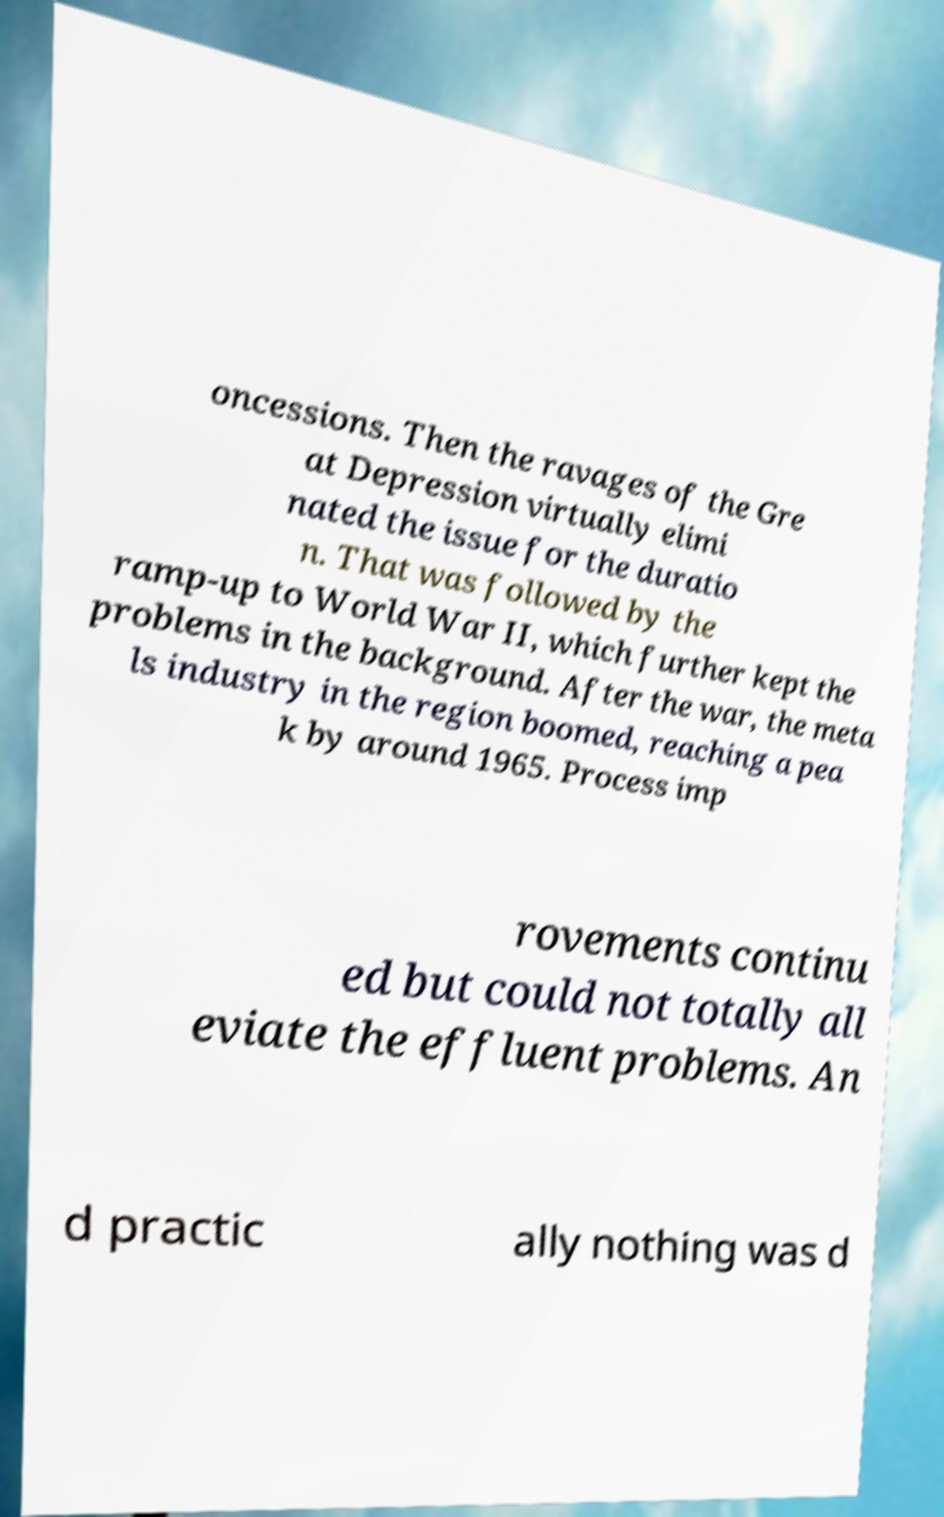Could you extract and type out the text from this image? oncessions. Then the ravages of the Gre at Depression virtually elimi nated the issue for the duratio n. That was followed by the ramp-up to World War II, which further kept the problems in the background. After the war, the meta ls industry in the region boomed, reaching a pea k by around 1965. Process imp rovements continu ed but could not totally all eviate the effluent problems. An d practic ally nothing was d 